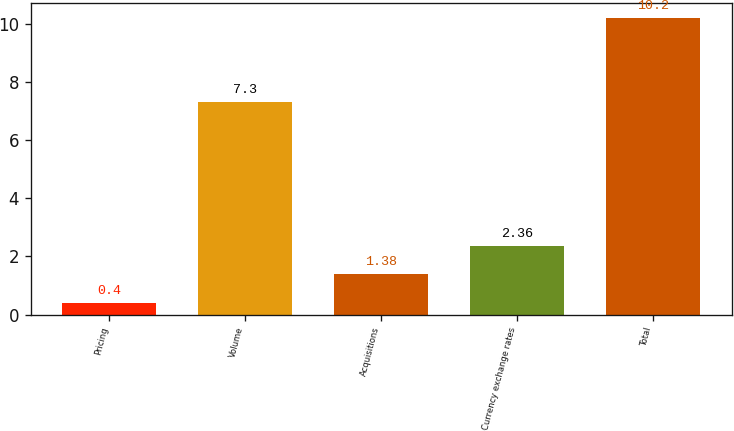<chart> <loc_0><loc_0><loc_500><loc_500><bar_chart><fcel>Pricing<fcel>Volume<fcel>Acquisitions<fcel>Currency exchange rates<fcel>Total<nl><fcel>0.4<fcel>7.3<fcel>1.38<fcel>2.36<fcel>10.2<nl></chart> 